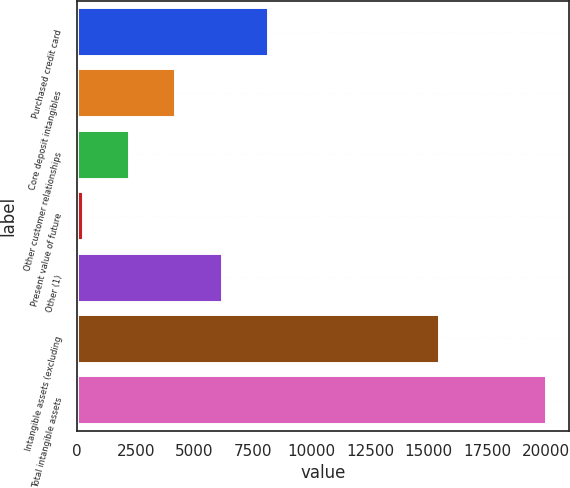Convert chart to OTSL. <chart><loc_0><loc_0><loc_500><loc_500><bar_chart><fcel>Purchased credit card<fcel>Core deposit intangibles<fcel>Other customer relationships<fcel>Present value of future<fcel>Other (1)<fcel>Intangible assets (excluding<fcel>Total intangible assets<nl><fcel>8147.8<fcel>4194.4<fcel>2217.7<fcel>241<fcel>6171.1<fcel>15454<fcel>20008<nl></chart> 